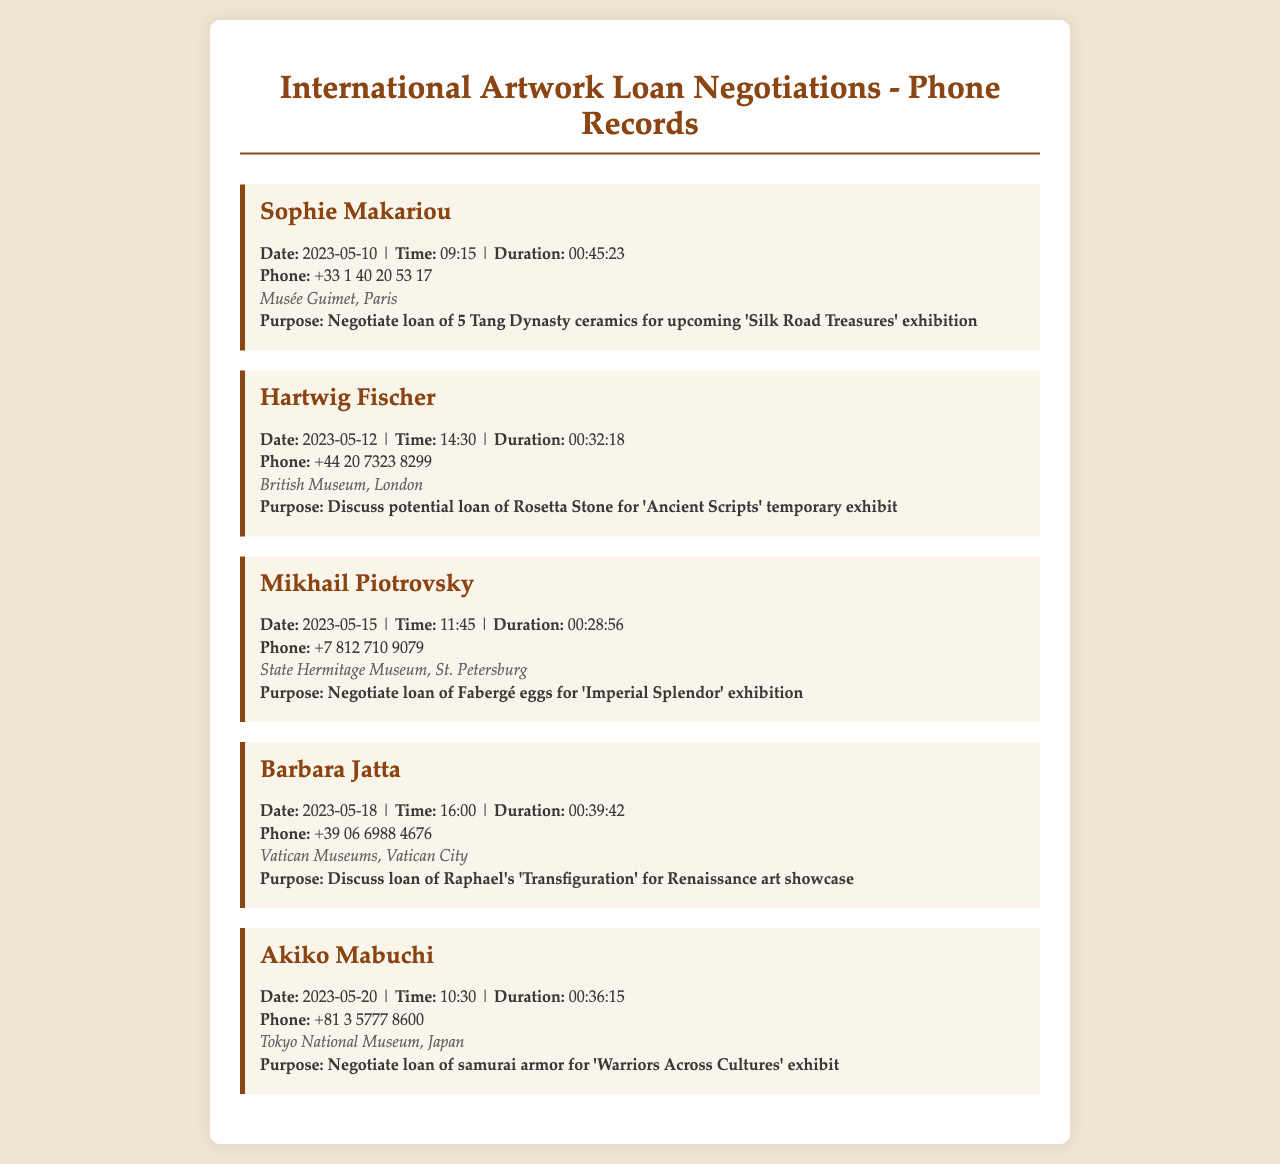what is the date of the call with Sophie Makariou? The date of the call with Sophie Makariou is found in the document entry detailing her communication, which is 2023-05-10.
Answer: 2023-05-10 how long was the call with Hartwig Fischer? The duration of Hartwig Fischer's call is provided in the entry for that record, which is 00:32:18.
Answer: 00:32:18 who is the representative from the Vatican Museums? The representative mentioned for the Vatican Museums in the document is Barbara Jatta.
Answer: Barbara Jatta what artwork is being discussed for loan from the State Hermitage Museum? The document specifies the artwork in discussion for loan from the State Hermitage Museum, which is Fabergé eggs.
Answer: Fabergé eggs which institution is negotiating the loan of samurai armor? The entry refers to the Tokyo National Museum when discussing the loan of samurai armor.
Answer: Tokyo National Museum what is the purpose of the call with Akiko Mabuchi? The purpose stated in the call record with Akiko Mabuchi is to negotiate a loan of samurai armor.
Answer: Negotiate loan of samurai armor how many Tang Dynasty ceramics are being negotiated by Sophie Makariou? The document indicates that 5 Tang Dynasty ceramics are being negotiated for loan in Sophie Makariou's call.
Answer: 5 Tang Dynasty ceramics which museum is involved in the loan negotiation for the Rosetta Stone? The British Museum is specifically mentioned as being involved in the loan negotiation for the Rosetta Stone.
Answer: British Museum how many phone calls are recorded in the document? The number of phone calls is determined by counting each record entry presented, totaling 5 calls.
Answer: 5 